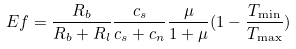Convert formula to latex. <formula><loc_0><loc_0><loc_500><loc_500>E f = { \frac { { R _ { b } } } { { R _ { b } + R _ { l } } } } { \frac { { c _ { s } } } { { c _ { s } + c _ { n } } } } { \frac { \mu } { 1 + \mu } } ( 1 - { \frac { { T _ { \min } } } { { T _ { \max } } } } )</formula> 